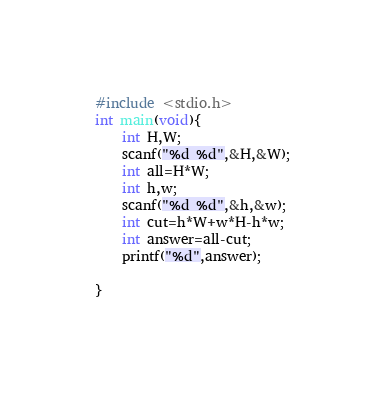Convert code to text. <code><loc_0><loc_0><loc_500><loc_500><_C_>#include <stdio.h>
int main(void){
    int H,W;
    scanf("%d %d",&H,&W);
    int all=H*W;
    int h,w;
    scanf("%d %d",&h,&w);
    int cut=h*W+w*H-h*w;
    int answer=all-cut;
    printf("%d",answer);
    
}
</code> 